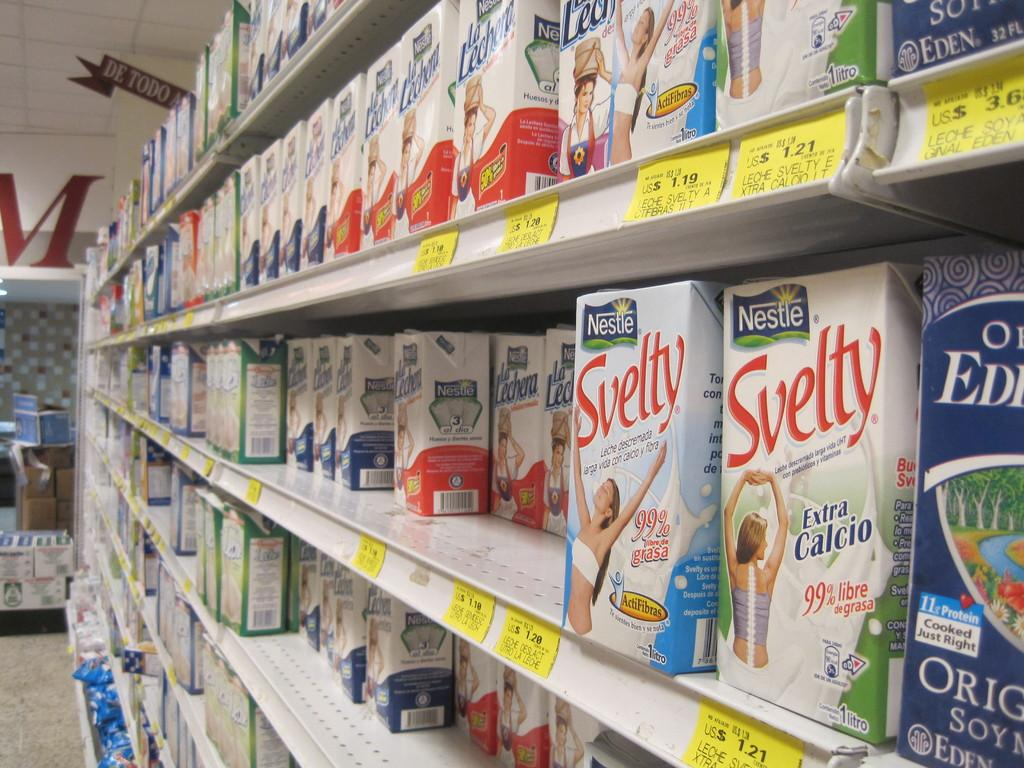<image>
Offer a succinct explanation of the picture presented. Boxes of Svelty are lined up on store shelves. 